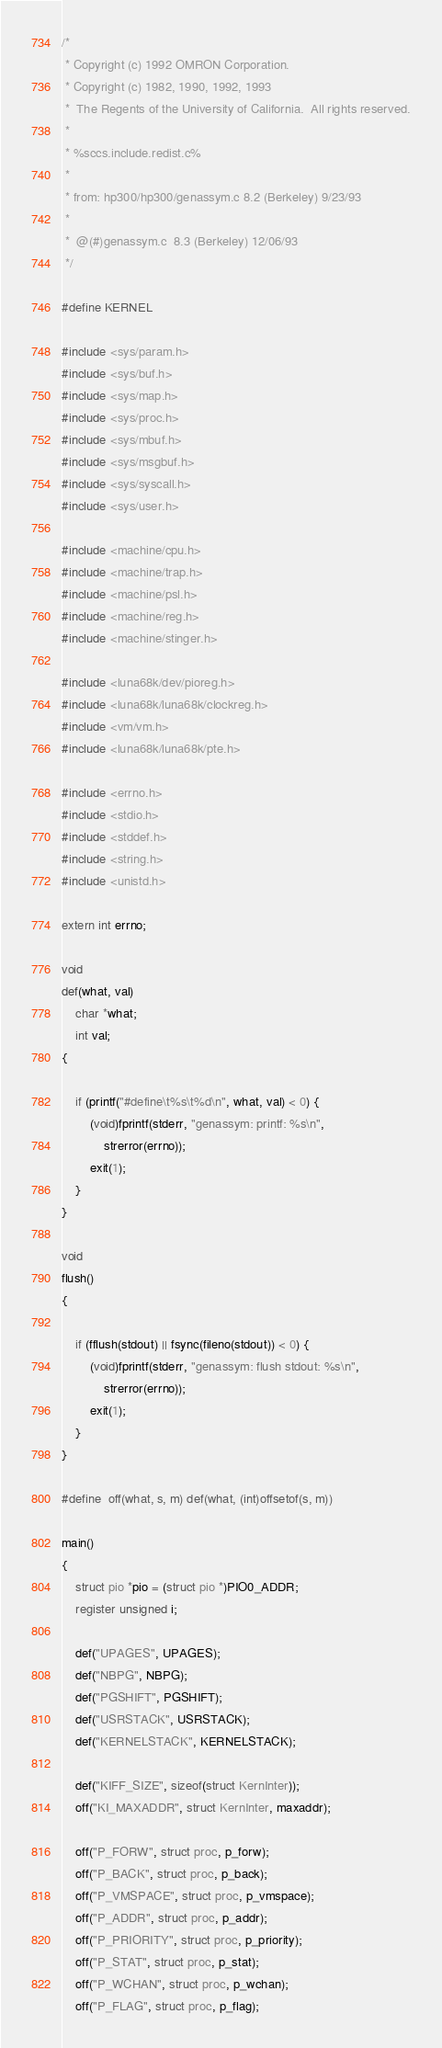Convert code to text. <code><loc_0><loc_0><loc_500><loc_500><_C_>/*
 * Copyright (c) 1992 OMRON Corporation.
 * Copyright (c) 1982, 1990, 1992, 1993
 *	The Regents of the University of California.  All rights reserved.
 *
 * %sccs.include.redist.c%
 *
 * from: hp300/hp300/genassym.c	8.2 (Berkeley) 9/23/93
 *
 *	@(#)genassym.c	8.3 (Berkeley) 12/06/93
 */

#define KERNEL

#include <sys/param.h>
#include <sys/buf.h>
#include <sys/map.h>
#include <sys/proc.h>
#include <sys/mbuf.h>
#include <sys/msgbuf.h>
#include <sys/syscall.h>
#include <sys/user.h>

#include <machine/cpu.h>
#include <machine/trap.h>
#include <machine/psl.h>
#include <machine/reg.h>
#include <machine/stinger.h>

#include <luna68k/dev/pioreg.h>
#include <luna68k/luna68k/clockreg.h>
#include <vm/vm.h>
#include <luna68k/luna68k/pte.h>

#include <errno.h>
#include <stdio.h>
#include <stddef.h>
#include <string.h>
#include <unistd.h>

extern int errno;

void
def(what, val)
	char *what;
	int val;
{

	if (printf("#define\t%s\t%d\n", what, val) < 0) {
		(void)fprintf(stderr, "genassym: printf: %s\n",
		    strerror(errno));
		exit(1);
	}
}

void
flush()
{

	if (fflush(stdout) || fsync(fileno(stdout)) < 0) {
		(void)fprintf(stderr, "genassym: flush stdout: %s\n",
		    strerror(errno));
		exit(1);
	}
}

#define	off(what, s, m)	def(what, (int)offsetof(s, m))

main()
{
	struct pio *pio = (struct pio *)PIO0_ADDR;
	register unsigned i;

	def("UPAGES", UPAGES);
	def("NBPG", NBPG);
	def("PGSHIFT", PGSHIFT);
	def("USRSTACK", USRSTACK);
	def("KERNELSTACK", KERNELSTACK);
	
	def("KIFF_SIZE", sizeof(struct KernInter));
	off("KI_MAXADDR", struct KernInter, maxaddr);

	off("P_FORW", struct proc, p_forw);
	off("P_BACK", struct proc, p_back);
	off("P_VMSPACE", struct proc, p_vmspace);
	off("P_ADDR", struct proc, p_addr);
	off("P_PRIORITY", struct proc, p_priority);
	off("P_STAT", struct proc, p_stat);
	off("P_WCHAN", struct proc, p_wchan);
	off("P_FLAG", struct proc, p_flag);</code> 